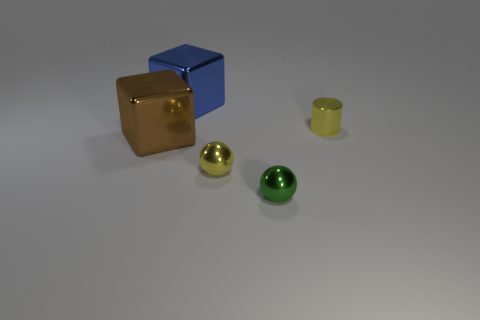Add 1 small green balls. How many small green balls exist? 2 Add 3 tiny yellow spheres. How many objects exist? 8 Subtract 0 cyan cylinders. How many objects are left? 5 Subtract all balls. How many objects are left? 3 Subtract 1 cylinders. How many cylinders are left? 0 Subtract all cyan balls. Subtract all blue cylinders. How many balls are left? 2 Subtract all brown cylinders. How many gray spheres are left? 0 Subtract all yellow shiny spheres. Subtract all tiny green cubes. How many objects are left? 4 Add 2 yellow balls. How many yellow balls are left? 3 